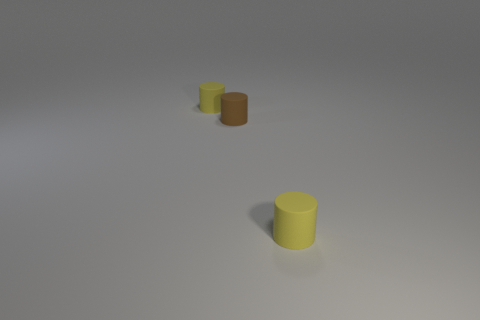What number of things are either yellow cylinders or small brown matte things?
Make the answer very short. 3. There is a tiny brown rubber thing; is its shape the same as the small thing that is to the left of the tiny brown cylinder?
Your answer should be very brief. Yes. What number of things are tiny yellow rubber objects that are behind the brown matte thing or yellow cylinders left of the brown rubber cylinder?
Offer a terse response. 1. What is the shape of the yellow object that is to the left of the tiny brown cylinder?
Offer a very short reply. Cylinder. There is a small yellow object behind the brown thing; is it the same shape as the small brown object?
Your answer should be very brief. Yes. What number of things are either tiny yellow objects that are in front of the tiny brown matte cylinder or tiny rubber objects?
Your answer should be very brief. 3. How big is the yellow cylinder that is in front of the tiny brown rubber cylinder?
Make the answer very short. Small. What number of other objects are the same material as the tiny brown thing?
Your answer should be very brief. 2. Are there more small cylinders than brown objects?
Your response must be concise. Yes. Are there any small brown cylinders that are on the right side of the tiny matte object that is to the right of the tiny brown cylinder?
Make the answer very short. No. 